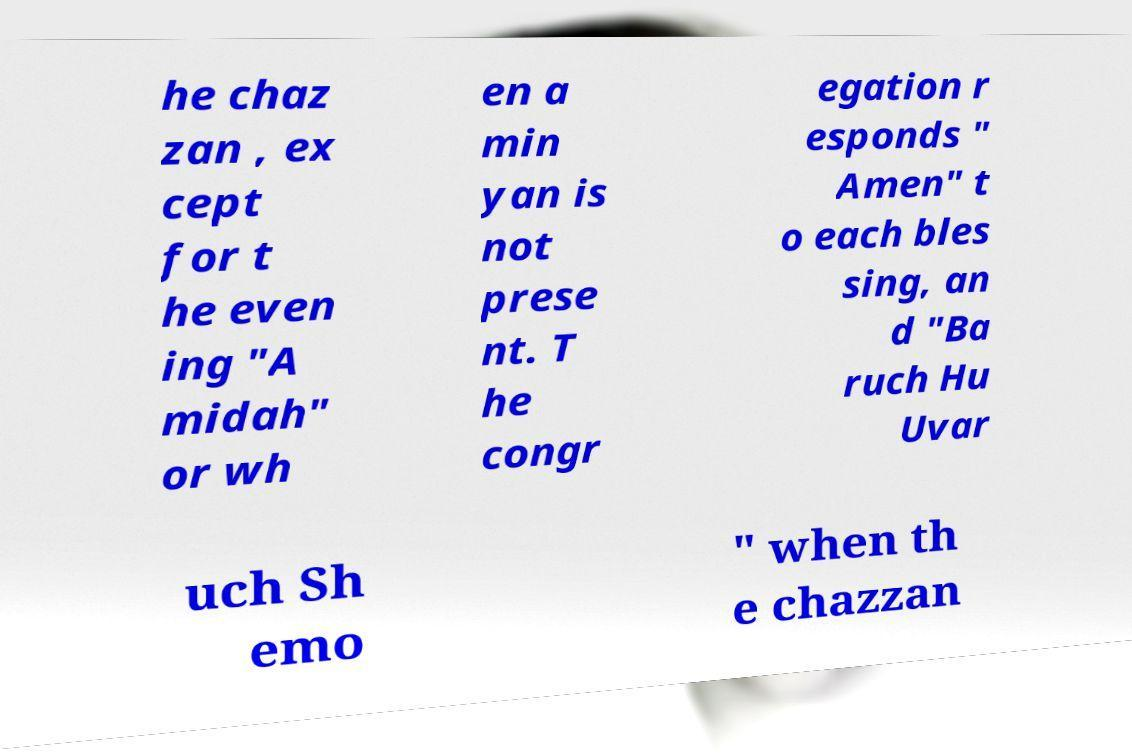What messages or text are displayed in this image? I need them in a readable, typed format. he chaz zan , ex cept for t he even ing "A midah" or wh en a min yan is not prese nt. T he congr egation r esponds " Amen" t o each bles sing, an d "Ba ruch Hu Uvar uch Sh emo " when th e chazzan 